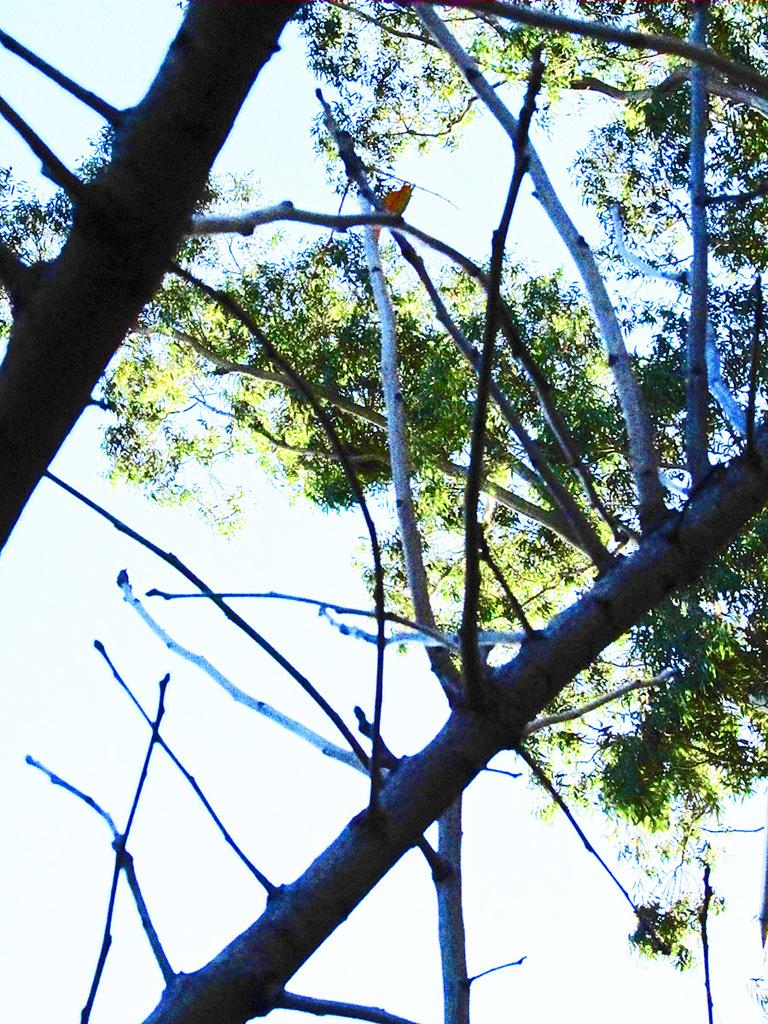What type of natural objects can be seen in the image? There are dried branches of a tree in the image. Can you describe the background of the image? There is another tree visible behind the dried branches. What type of behavior can be observed in the planes flying over the trees in the image? There are no planes visible in the image, so no behavior can be observed. 